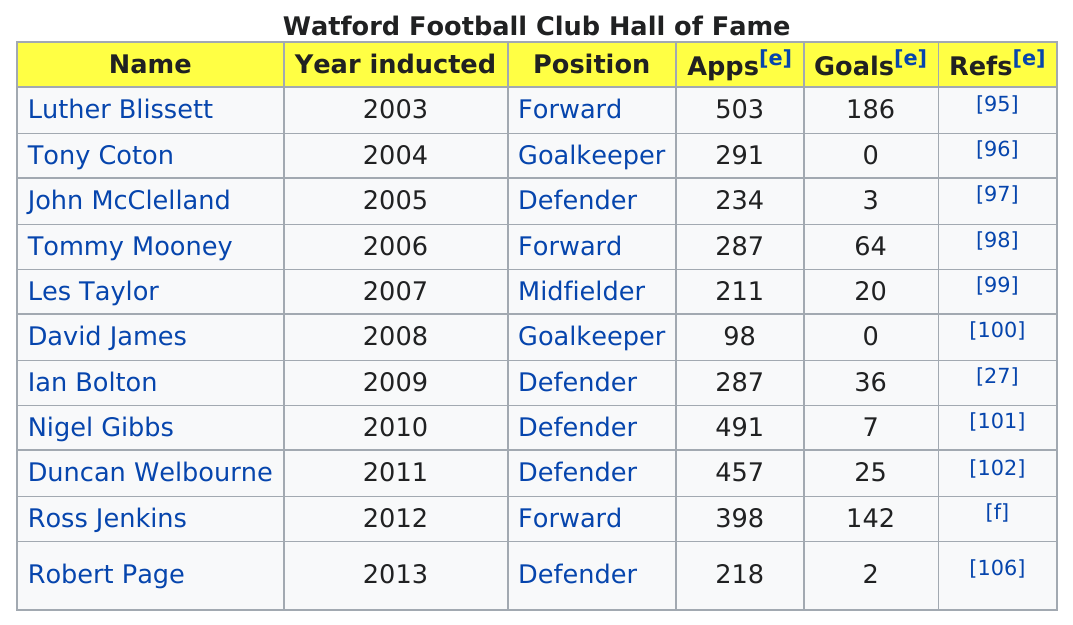Mention a couple of crucial points in this snapshot. Luther Blissett was the player who had the most apps. The total number of apps and goals for Luther Blissett is 689. Luther Blissett has the most goals. The Hall of Fame player awarded the year after Tony Coton earned more goals than he did. The last player to be inducted is Robert Page. 